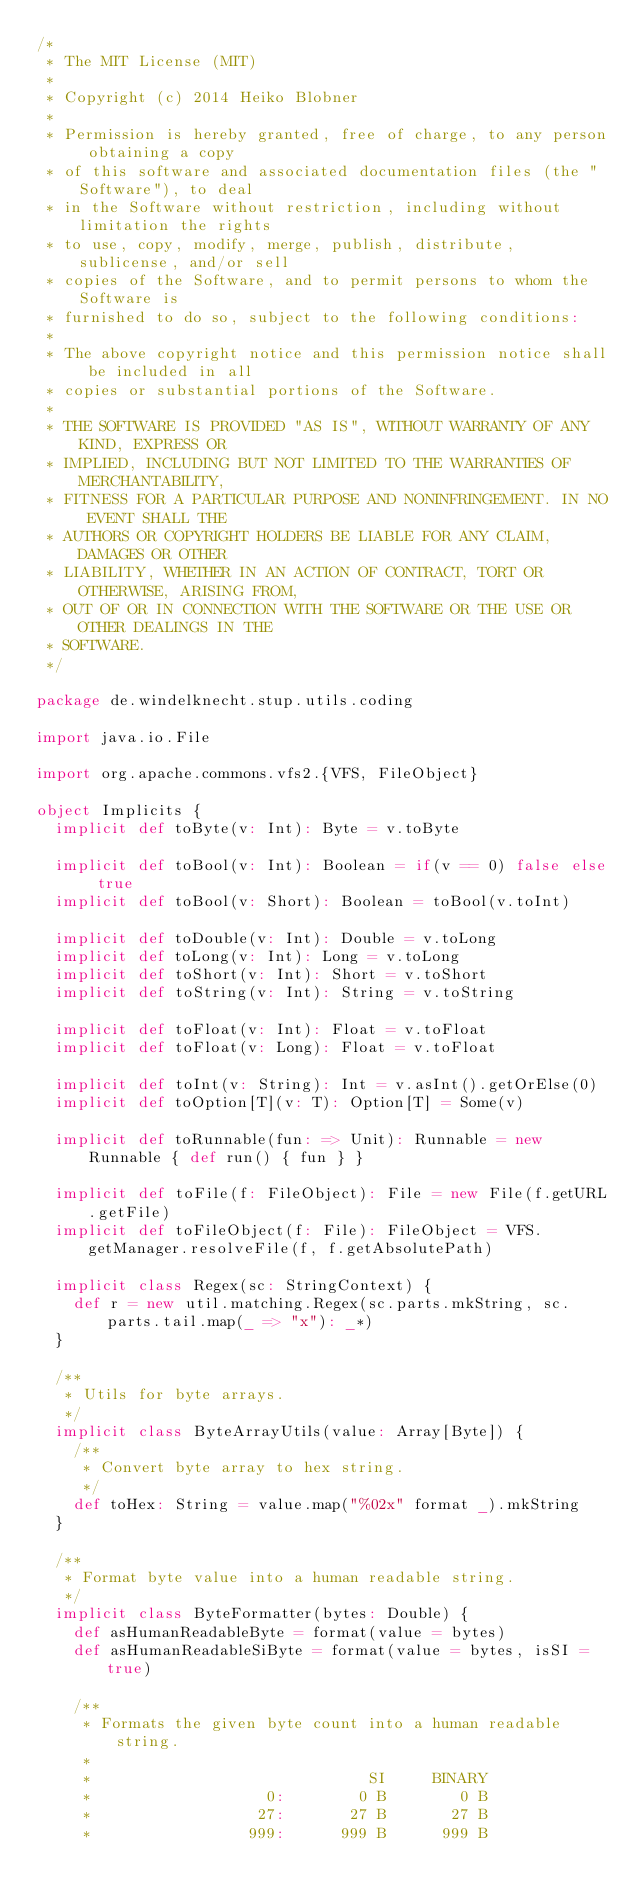Convert code to text. <code><loc_0><loc_0><loc_500><loc_500><_Scala_>/*
 * The MIT License (MIT)
 *
 * Copyright (c) 2014 Heiko Blobner
 *
 * Permission is hereby granted, free of charge, to any person obtaining a copy
 * of this software and associated documentation files (the "Software"), to deal
 * in the Software without restriction, including without limitation the rights
 * to use, copy, modify, merge, publish, distribute, sublicense, and/or sell
 * copies of the Software, and to permit persons to whom the Software is
 * furnished to do so, subject to the following conditions:
 *
 * The above copyright notice and this permission notice shall be included in all
 * copies or substantial portions of the Software.
 *
 * THE SOFTWARE IS PROVIDED "AS IS", WITHOUT WARRANTY OF ANY KIND, EXPRESS OR
 * IMPLIED, INCLUDING BUT NOT LIMITED TO THE WARRANTIES OF MERCHANTABILITY,
 * FITNESS FOR A PARTICULAR PURPOSE AND NONINFRINGEMENT. IN NO EVENT SHALL THE
 * AUTHORS OR COPYRIGHT HOLDERS BE LIABLE FOR ANY CLAIM, DAMAGES OR OTHER
 * LIABILITY, WHETHER IN AN ACTION OF CONTRACT, TORT OR OTHERWISE, ARISING FROM,
 * OUT OF OR IN CONNECTION WITH THE SOFTWARE OR THE USE OR OTHER DEALINGS IN THE
 * SOFTWARE.
 */

package de.windelknecht.stup.utils.coding

import java.io.File

import org.apache.commons.vfs2.{VFS, FileObject}

object Implicits {
  implicit def toByte(v: Int): Byte = v.toByte

  implicit def toBool(v: Int): Boolean = if(v == 0) false else true
  implicit def toBool(v: Short): Boolean = toBool(v.toInt)

  implicit def toDouble(v: Int): Double = v.toLong
  implicit def toLong(v: Int): Long = v.toLong
  implicit def toShort(v: Int): Short = v.toShort
  implicit def toString(v: Int): String = v.toString

  implicit def toFloat(v: Int): Float = v.toFloat
  implicit def toFloat(v: Long): Float = v.toFloat

  implicit def toInt(v: String): Int = v.asInt().getOrElse(0)
  implicit def toOption[T](v: T): Option[T] = Some(v)

  implicit def toRunnable(fun: => Unit): Runnable = new Runnable { def run() { fun } }

  implicit def toFile(f: FileObject): File = new File(f.getURL.getFile)
  implicit def toFileObject(f: File): FileObject = VFS.getManager.resolveFile(f, f.getAbsolutePath)

  implicit class Regex(sc: StringContext) {
    def r = new util.matching.Regex(sc.parts.mkString, sc.parts.tail.map(_ => "x"): _*)
  }

  /**
   * Utils for byte arrays.
   */
  implicit class ByteArrayUtils(value: Array[Byte]) {
    /**
     * Convert byte array to hex string.
     */
    def toHex: String = value.map("%02x" format _).mkString
  }

  /**
   * Format byte value into a human readable string.
   */
  implicit class ByteFormatter(bytes: Double) {
    def asHumanReadableByte = format(value = bytes)
    def asHumanReadableSiByte = format(value = bytes, isSI = true)

    /**
     * Formats the given byte count into a human readable string.
     *
     *                              SI     BINARY
     *                   0:        0 B        0 B
     *                  27:       27 B       27 B
     *                 999:      999 B      999 B</code> 